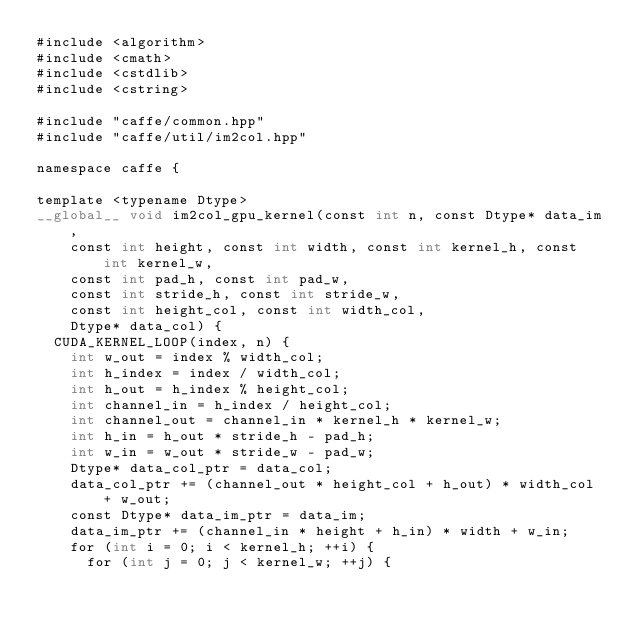<code> <loc_0><loc_0><loc_500><loc_500><_Cuda_>#include <algorithm>
#include <cmath>
#include <cstdlib>
#include <cstring>

#include "caffe/common.hpp"
#include "caffe/util/im2col.hpp"

namespace caffe {

template <typename Dtype>
__global__ void im2col_gpu_kernel(const int n, const Dtype* data_im,
    const int height, const int width, const int kernel_h, const int kernel_w,
    const int pad_h, const int pad_w,
    const int stride_h, const int stride_w,
    const int height_col, const int width_col,
    Dtype* data_col) {
  CUDA_KERNEL_LOOP(index, n) {
    int w_out = index % width_col;
    int h_index = index / width_col;
    int h_out = h_index % height_col;
    int channel_in = h_index / height_col;
    int channel_out = channel_in * kernel_h * kernel_w;
    int h_in = h_out * stride_h - pad_h;
    int w_in = w_out * stride_w - pad_w;
    Dtype* data_col_ptr = data_col;
    data_col_ptr += (channel_out * height_col + h_out) * width_col + w_out;
    const Dtype* data_im_ptr = data_im;
    data_im_ptr += (channel_in * height + h_in) * width + w_in;
    for (int i = 0; i < kernel_h; ++i) {
      for (int j = 0; j < kernel_w; ++j) {</code> 